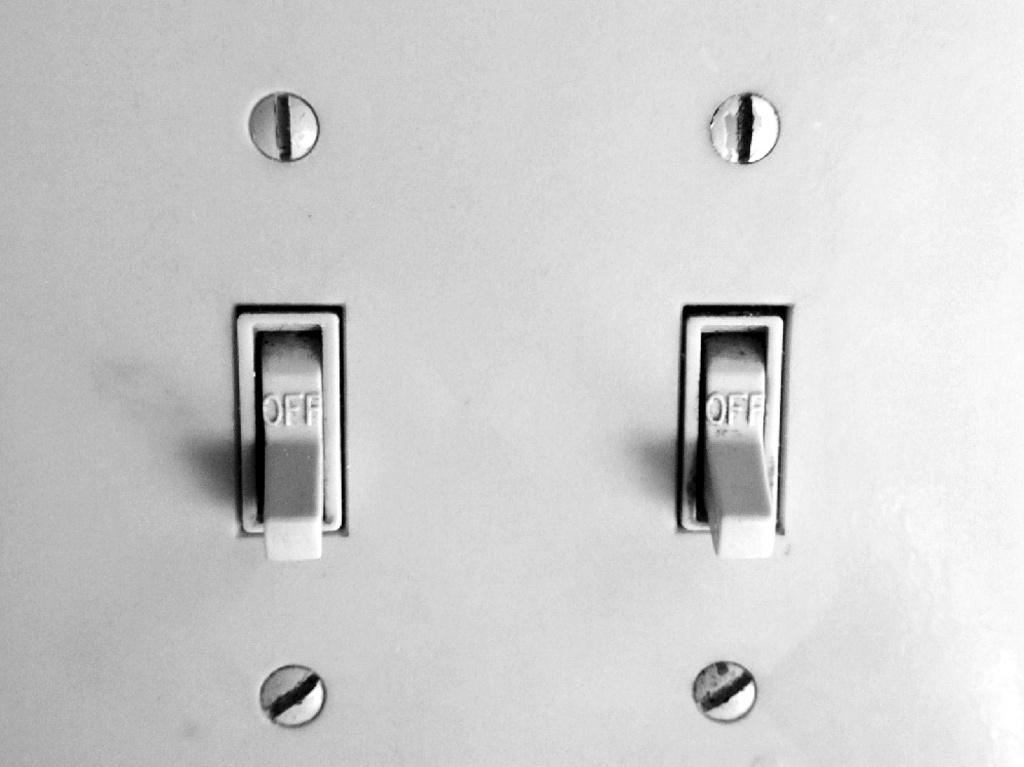What is the main object in the image? There is a board in the image. What features can be seen on the board? The board has switches and screws. What type of grain is visible on the board in the image? There is no grain visible on the board in the image. Is there a carpenter working on the board in the image? There is no carpenter present in the image. 